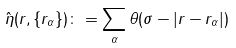Convert formula to latex. <formula><loc_0><loc_0><loc_500><loc_500>\hat { \eta } ( { r } , \{ { r } _ { \alpha } \} ) \colon = \sum _ { \alpha } \theta ( \sigma - | { r } - { r } _ { \alpha } | )</formula> 